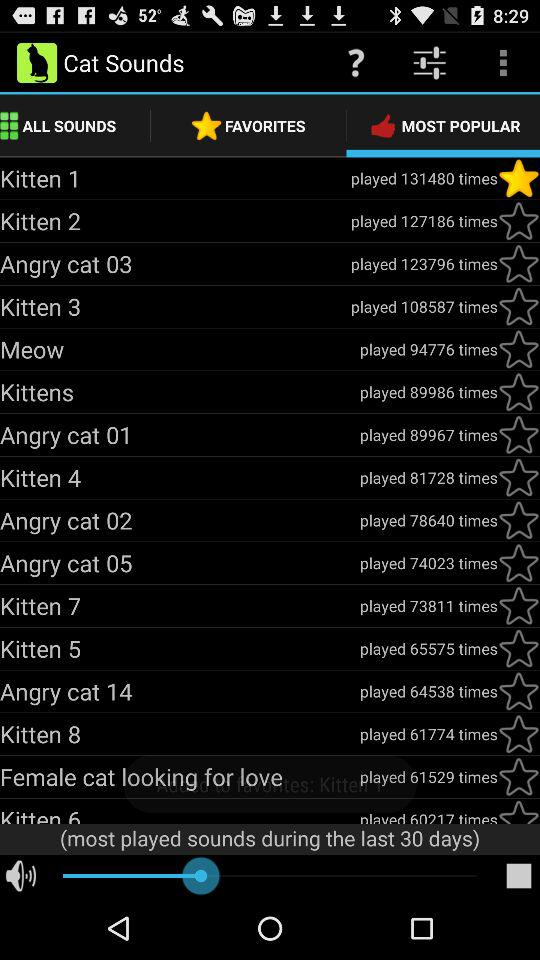How many times is the "Meow" sound played? The "Meow" sound is played 94776 times. 